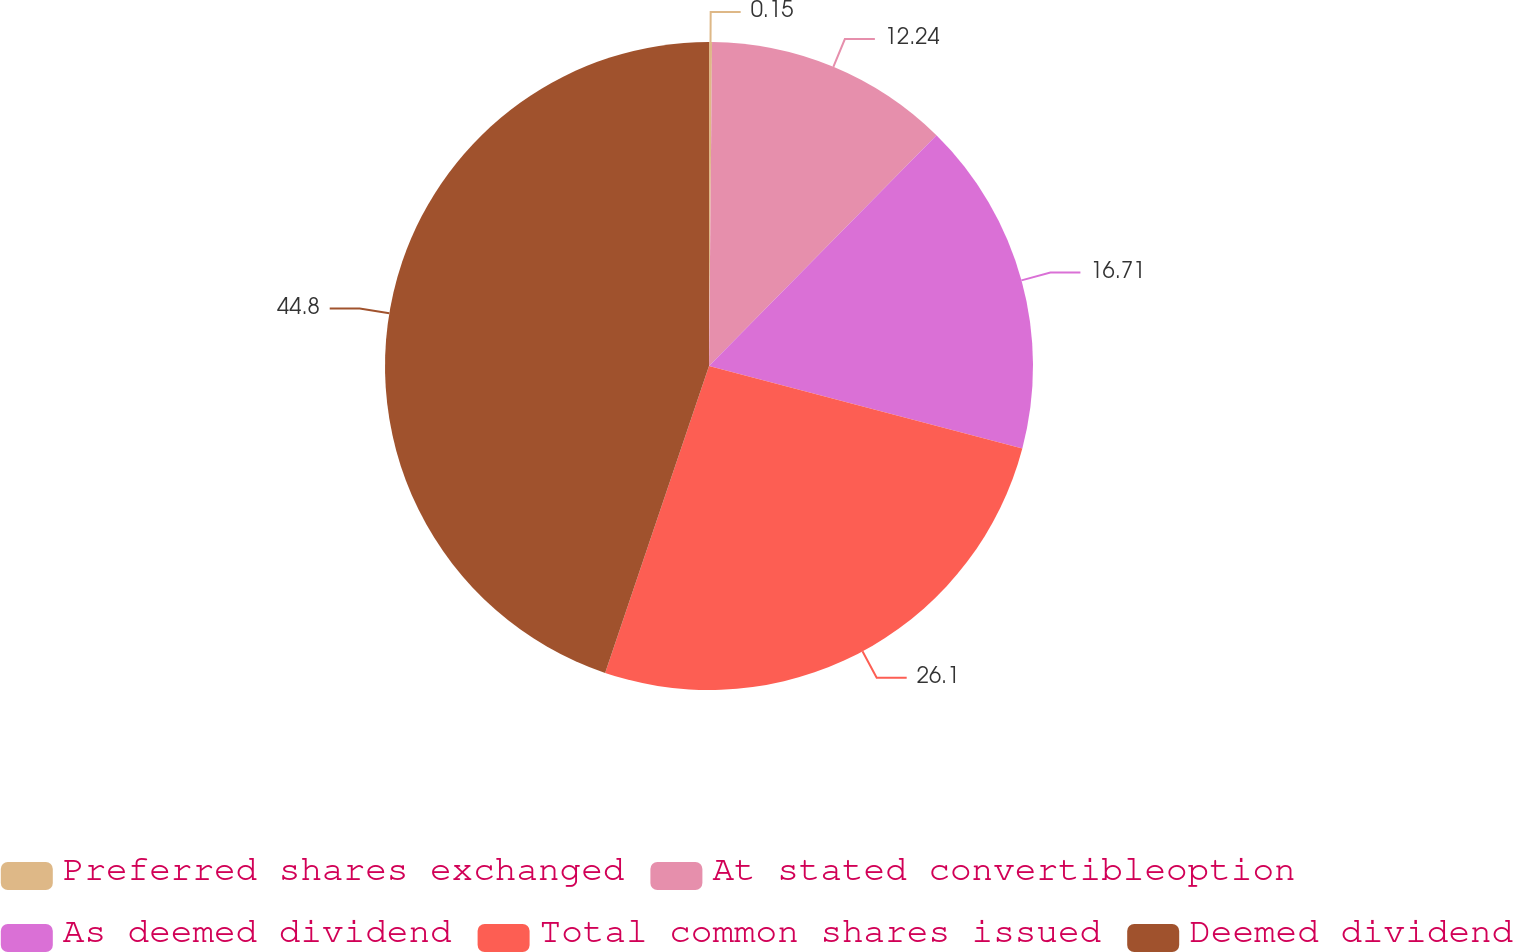Convert chart to OTSL. <chart><loc_0><loc_0><loc_500><loc_500><pie_chart><fcel>Preferred shares exchanged<fcel>At stated convertibleoption<fcel>As deemed dividend<fcel>Total common shares issued<fcel>Deemed dividend<nl><fcel>0.15%<fcel>12.24%<fcel>16.71%<fcel>26.1%<fcel>44.81%<nl></chart> 